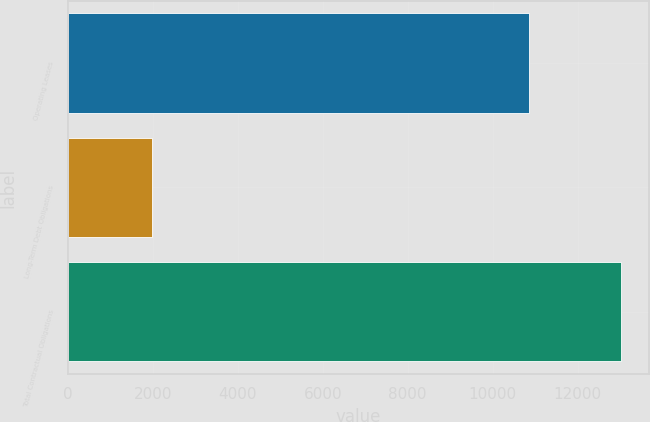Convert chart to OTSL. <chart><loc_0><loc_0><loc_500><loc_500><bar_chart><fcel>Operating Leases<fcel>Long-Term Debt Obligations<fcel>Total Contractual Obligations<nl><fcel>10857<fcel>1977<fcel>13034<nl></chart> 